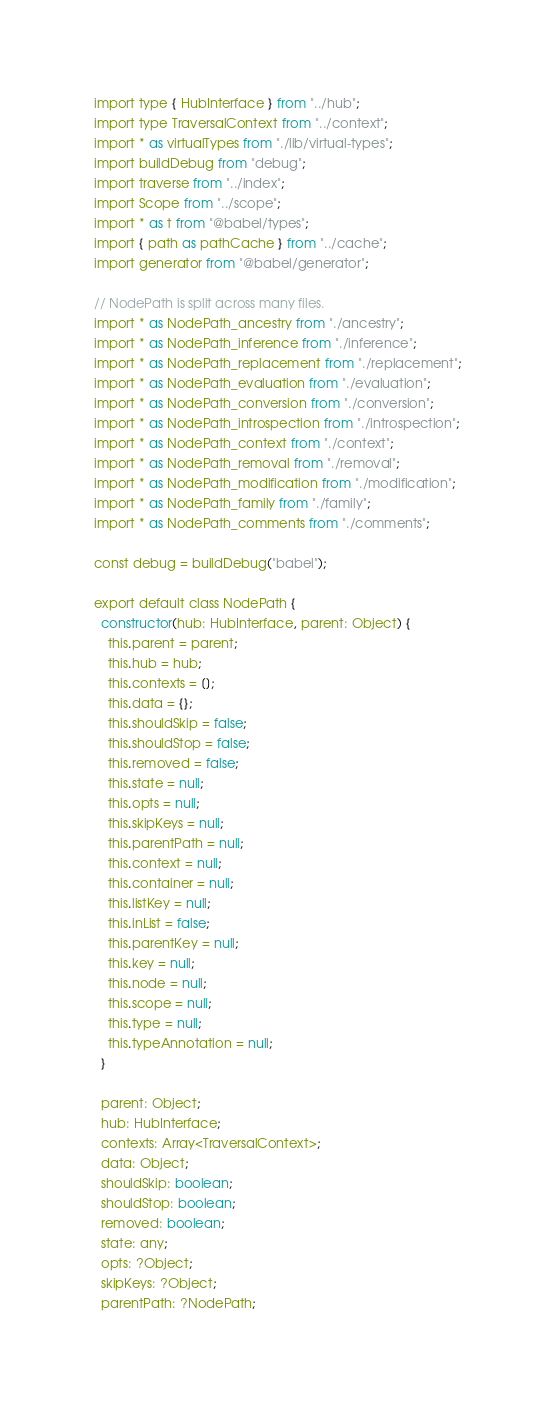Convert code to text. <code><loc_0><loc_0><loc_500><loc_500><_JavaScript_>import type { HubInterface } from "../hub";
import type TraversalContext from "../context";
import * as virtualTypes from "./lib/virtual-types";
import buildDebug from "debug";
import traverse from "../index";
import Scope from "../scope";
import * as t from "@babel/types";
import { path as pathCache } from "../cache";
import generator from "@babel/generator";

// NodePath is split across many files.
import * as NodePath_ancestry from "./ancestry";
import * as NodePath_inference from "./inference";
import * as NodePath_replacement from "./replacement";
import * as NodePath_evaluation from "./evaluation";
import * as NodePath_conversion from "./conversion";
import * as NodePath_introspection from "./introspection";
import * as NodePath_context from "./context";
import * as NodePath_removal from "./removal";
import * as NodePath_modification from "./modification";
import * as NodePath_family from "./family";
import * as NodePath_comments from "./comments";

const debug = buildDebug("babel");

export default class NodePath {
  constructor(hub: HubInterface, parent: Object) {
    this.parent = parent;
    this.hub = hub;
    this.contexts = [];
    this.data = {};
    this.shouldSkip = false;
    this.shouldStop = false;
    this.removed = false;
    this.state = null;
    this.opts = null;
    this.skipKeys = null;
    this.parentPath = null;
    this.context = null;
    this.container = null;
    this.listKey = null;
    this.inList = false;
    this.parentKey = null;
    this.key = null;
    this.node = null;
    this.scope = null;
    this.type = null;
    this.typeAnnotation = null;
  }

  parent: Object;
  hub: HubInterface;
  contexts: Array<TraversalContext>;
  data: Object;
  shouldSkip: boolean;
  shouldStop: boolean;
  removed: boolean;
  state: any;
  opts: ?Object;
  skipKeys: ?Object;
  parentPath: ?NodePath;</code> 